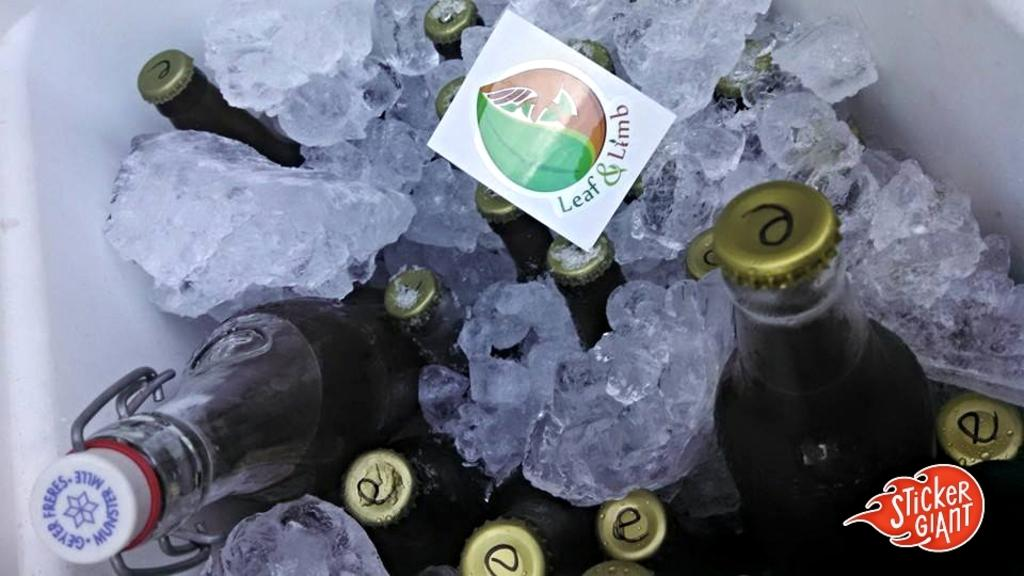What is the main object in the image? There is a box in the image. What is inside the box? The box contains a group of bottles and ice cubes. How are the ice cubes positioned in the box? There are ice cubes in the box, and a sticker is on top of them. Is there any additional information about the image? Yes, the image has a watermark. What type of rose can be seen growing next to the cactus in the image? There is no rose or cactus present in the image; it only features a box with bottles and ice cubes. What type of prison is depicted in the image? There is no prison present in the image; it only features a box with bottles and ice cubes. 